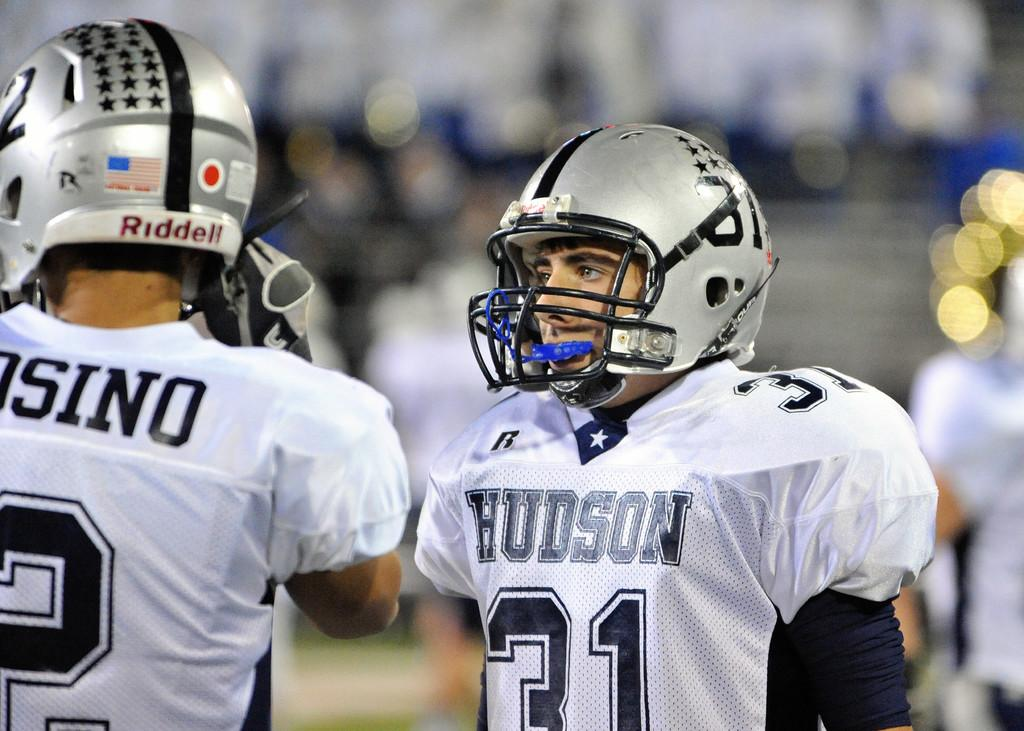How many people are in the image? There are two persons in the image. What are the people wearing that is similar? Both persons are wearing the same dress. What protective gear are the people wearing? Both persons are wearing helmets. What type of mine can be seen in the image? There is no mine present in the image. What is the current situation of the people in the image? The provided facts do not give any information about the current situation or emotional state of the people in the image. 